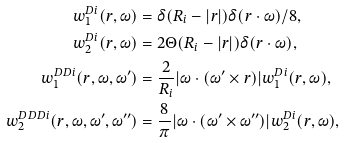<formula> <loc_0><loc_0><loc_500><loc_500>w _ { 1 } ^ { D i } ( r , \omega ) & = \delta ( R _ { i } - | r | ) \delta ( r \cdot \omega ) / 8 , \\ w _ { 2 } ^ { D i } ( r , \omega ) & = 2 \Theta ( R _ { i } - | r | ) \delta ( r \cdot \omega ) , \\ w _ { 1 } ^ { D D i } ( r , \omega , \omega ^ { \prime } ) & = \frac { 2 } { R _ { i } } | \omega \cdot ( \omega ^ { \prime } \times r ) | w _ { 1 } ^ { D i } ( r , \omega ) , \\ w _ { 2 } ^ { D D D i } ( r , \omega , \omega ^ { \prime } , \omega ^ { \prime \prime } ) & = \frac { 8 } { \pi } | \omega \cdot ( \omega ^ { \prime } \times \omega ^ { \prime \prime } ) | w _ { 2 } ^ { D i } ( r , \omega ) ,</formula> 